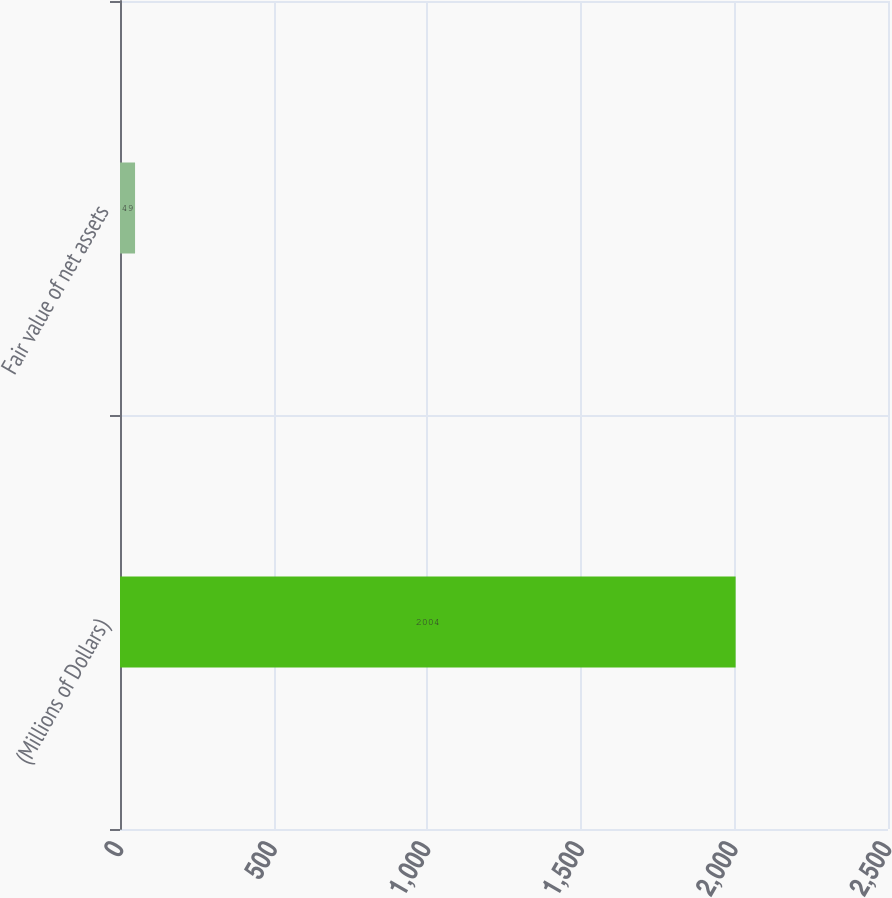Convert chart. <chart><loc_0><loc_0><loc_500><loc_500><bar_chart><fcel>(Millions of Dollars)<fcel>Fair value of net assets<nl><fcel>2004<fcel>49<nl></chart> 